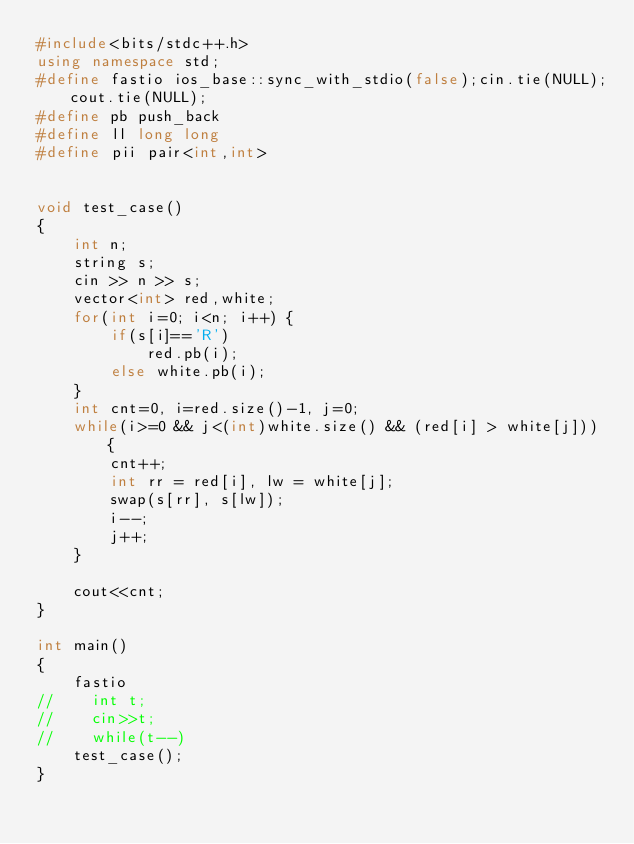<code> <loc_0><loc_0><loc_500><loc_500><_C++_>#include<bits/stdc++.h>
using namespace std;
#define fastio ios_base::sync_with_stdio(false);cin.tie(NULL);cout.tie(NULL);
#define pb push_back
#define ll long long
#define pii pair<int,int>


void test_case()
{
    int n;
    string s;
    cin >> n >> s;
    vector<int> red,white;
    for(int i=0; i<n; i++) {
        if(s[i]=='R')
            red.pb(i);
        else white.pb(i);
    }
    int cnt=0, i=red.size()-1, j=0;
    while(i>=0 && j<(int)white.size() && (red[i] > white[j])) {
        cnt++;
        int rr = red[i], lw = white[j];
        swap(s[rr], s[lw]);
        i--;
        j++;
    }

    cout<<cnt;
}

int main()
{
    fastio
//    int t;
//    cin>>t;
//    while(t--)
    test_case();
}
</code> 